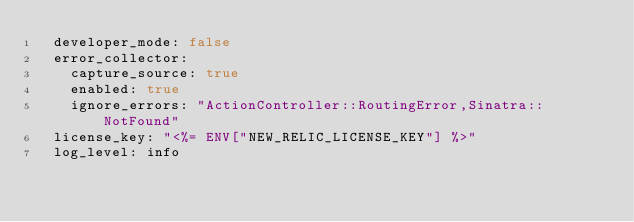Convert code to text. <code><loc_0><loc_0><loc_500><loc_500><_YAML_>  developer_mode: false
  error_collector:
    capture_source: true
    enabled: true
    ignore_errors: "ActionController::RoutingError,Sinatra::NotFound"
  license_key: "<%= ENV["NEW_RELIC_LICENSE_KEY"] %>"
  log_level: info</code> 